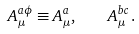Convert formula to latex. <formula><loc_0><loc_0><loc_500><loc_500>A _ { \mu } ^ { a \phi } \equiv A _ { \mu } ^ { a } , \quad A _ { \mu } ^ { b c } \, . \\</formula> 